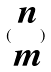<formula> <loc_0><loc_0><loc_500><loc_500>( \begin{matrix} n \\ m \end{matrix} )</formula> 